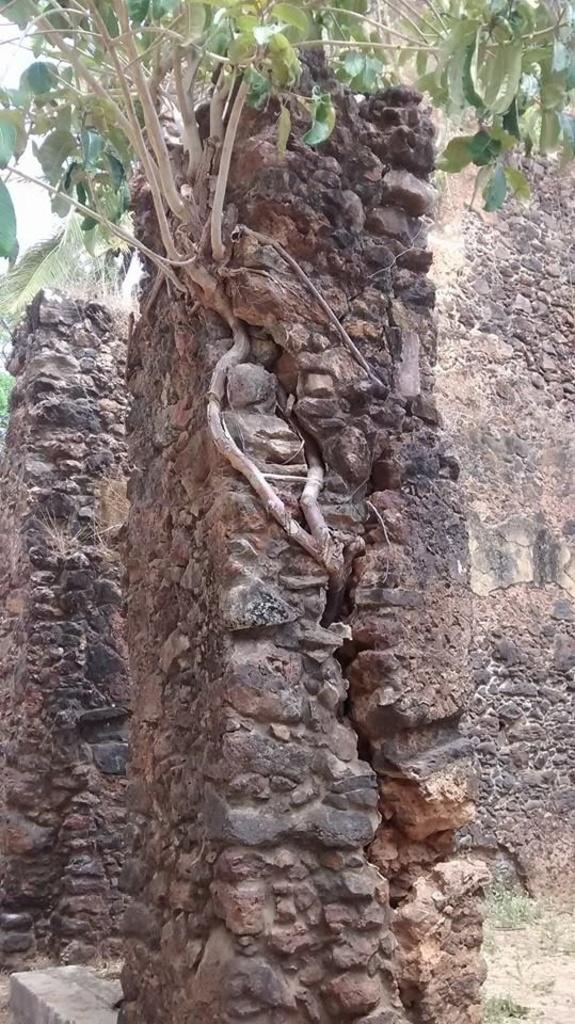What is one of the main features in the image? There is a wall in the image. Can you describe any other objects or elements in the image? There is a plant on a pillar in the image. What request does the maid make to the aunt in the image? There is no maid or aunt present in the image, so it is not possible to answer that question. 